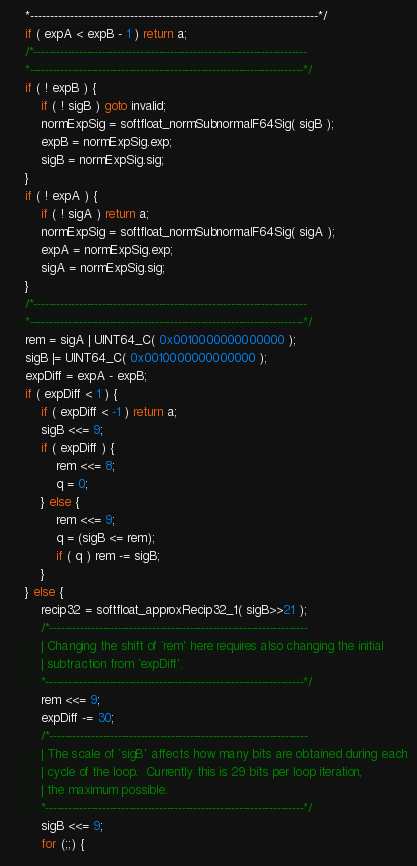Convert code to text. <code><loc_0><loc_0><loc_500><loc_500><_C_>    *------------------------------------------------------------------------*/
    if ( expA < expB - 1 ) return a;
    /*------------------------------------------------------------------------
    *------------------------------------------------------------------------*/
    if ( ! expB ) {
        if ( ! sigB ) goto invalid;
        normExpSig = softfloat_normSubnormalF64Sig( sigB );
        expB = normExpSig.exp;
        sigB = normExpSig.sig;
    }
    if ( ! expA ) {
        if ( ! sigA ) return a;
        normExpSig = softfloat_normSubnormalF64Sig( sigA );
        expA = normExpSig.exp;
        sigA = normExpSig.sig;
    }
    /*------------------------------------------------------------------------
    *------------------------------------------------------------------------*/
    rem = sigA | UINT64_C( 0x0010000000000000 );
    sigB |= UINT64_C( 0x0010000000000000 );
    expDiff = expA - expB;
    if ( expDiff < 1 ) {
        if ( expDiff < -1 ) return a;
        sigB <<= 9;
        if ( expDiff ) {
            rem <<= 8;
            q = 0;
        } else {
            rem <<= 9;
            q = (sigB <= rem);
            if ( q ) rem -= sigB;
        }
    } else {
        recip32 = softfloat_approxRecip32_1( sigB>>21 );
        /*--------------------------------------------------------------------
        | Changing the shift of `rem' here requires also changing the initial
        | subtraction from `expDiff'.
        *--------------------------------------------------------------------*/
        rem <<= 9;
        expDiff -= 30;
        /*--------------------------------------------------------------------
        | The scale of `sigB' affects how many bits are obtained during each
        | cycle of the loop.  Currently this is 29 bits per loop iteration,
        | the maximum possible.
        *--------------------------------------------------------------------*/
        sigB <<= 9;
        for (;;) {</code> 